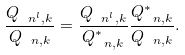<formula> <loc_0><loc_0><loc_500><loc_500>\frac { Q _ { \ n ^ { l } , k } } { Q _ { \ n , k } } = \frac { Q _ { \ n ^ { l } , k } } { Q _ { \ n , k } ^ { * } } \frac { Q _ { \ n , k } ^ { * } } { Q _ { \ n , k } } .</formula> 